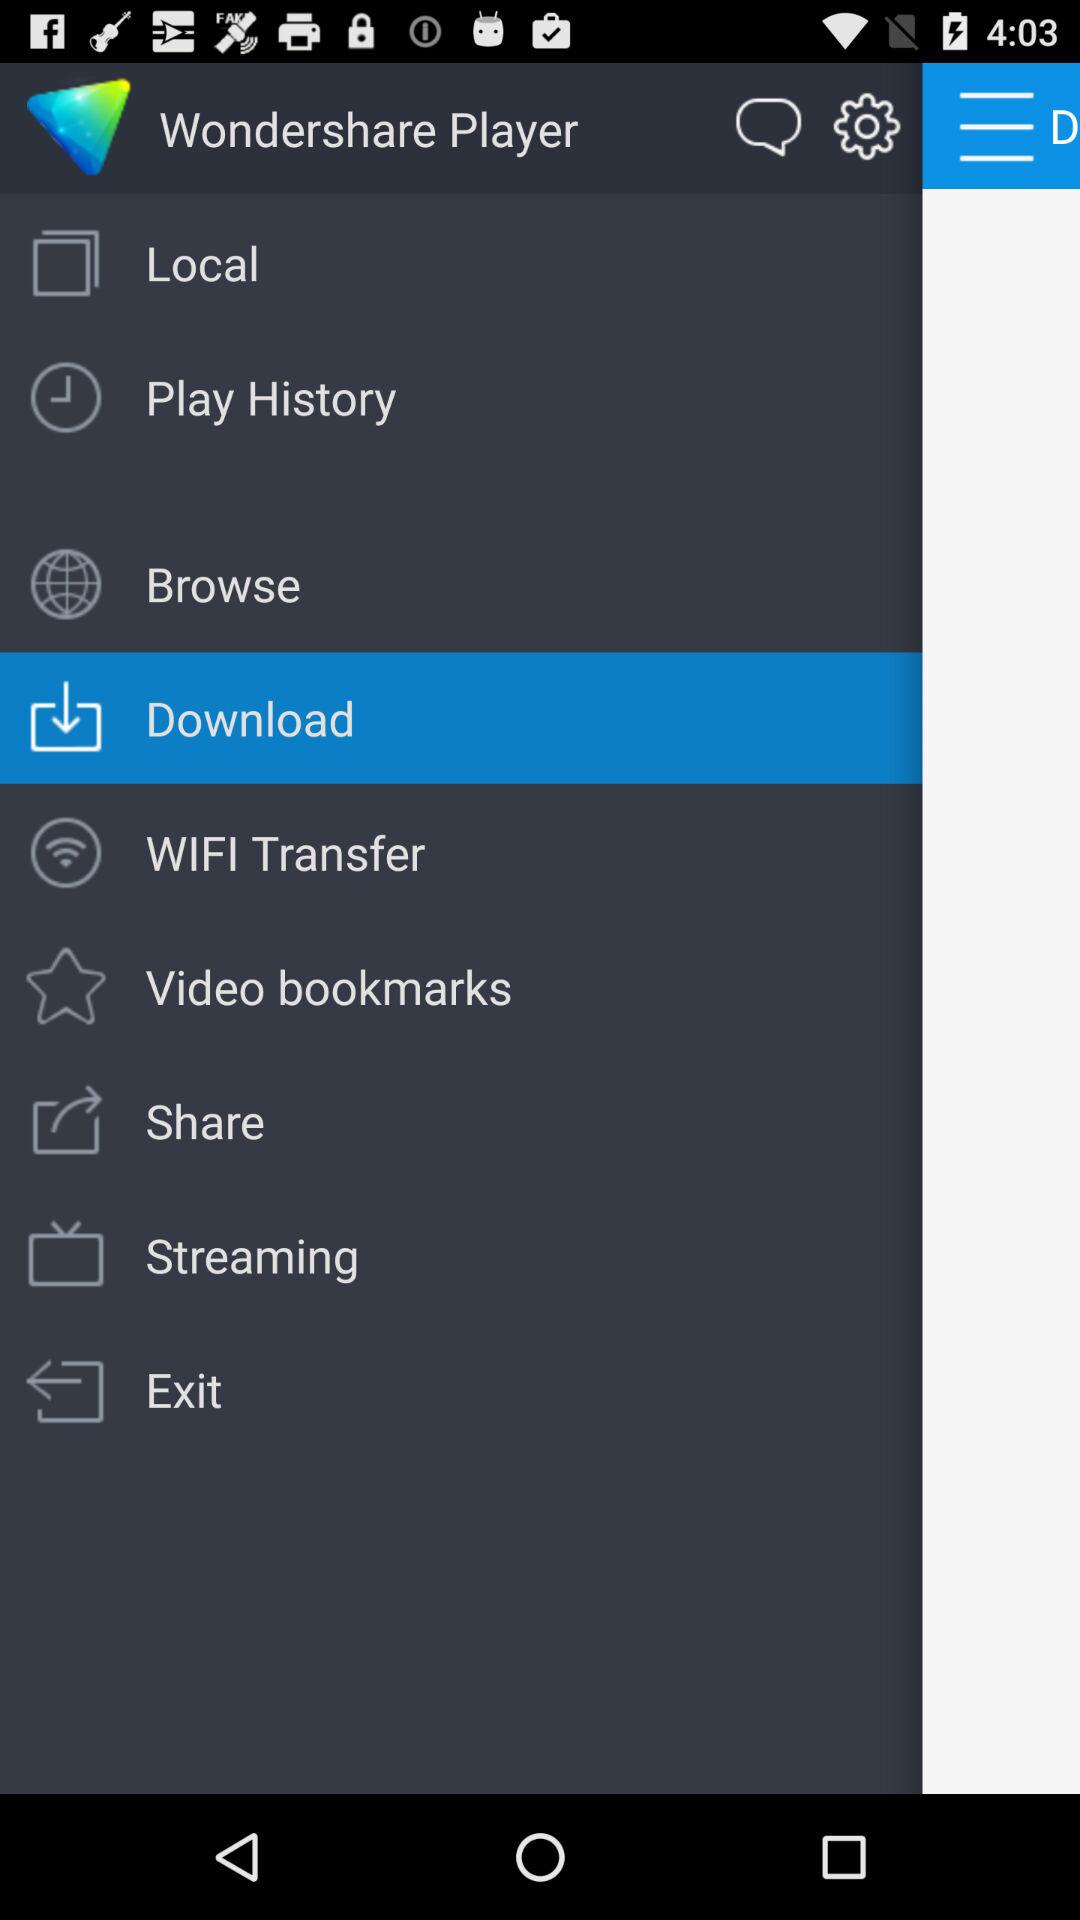What option is selected? The selected option is "Download". 